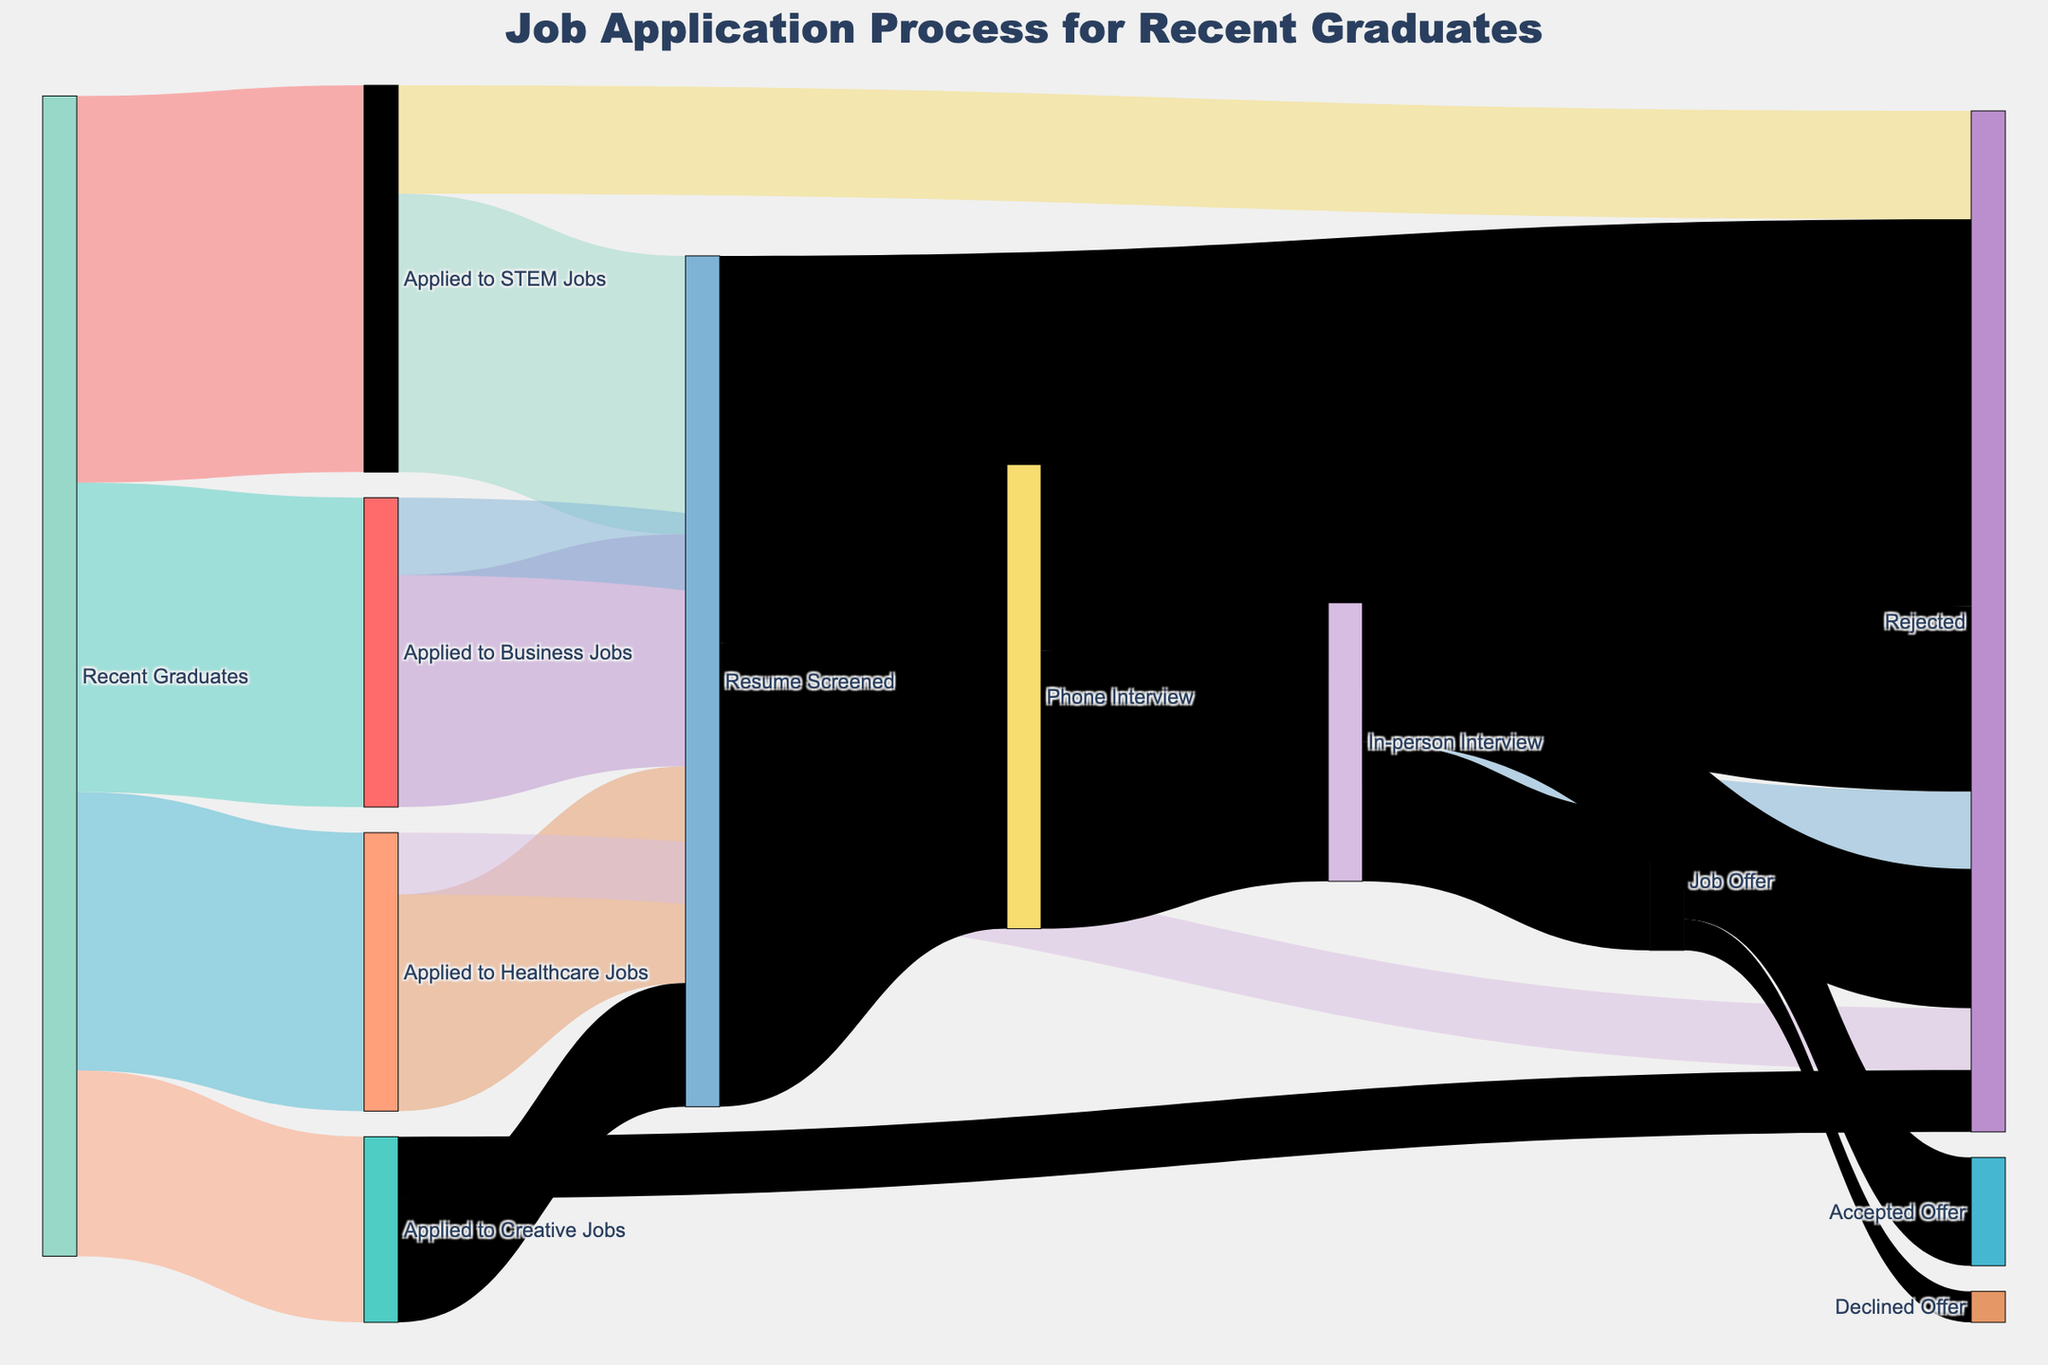What's the title of the diagram? Look at the top center of the diagram where the title is generally placed. The title summarizes the purpose of the diagram.
Answer: Job Application Process for Recent Graduates Which sector received the most applications? Follow the flows starting from "Recent Graduates" to each job sector. The thickness of the flow represents the number of applications.
Answer: STEM Jobs How many graduates' resumes were screened in total across all sectors? Sum the values of resumes screened in each sector: STEM Jobs (1800), Business Jobs (1500), Healthcare Jobs (1400), Creative Jobs (800). 1800 + 1500 + 1400 + 800 = 5500.
Answer: 5500 Compare the number of phone interviews after resume screening and the number of rejections from resume screening. Which is higher? The flow from "Resume Screened" to "Phone Interview" is 3000, and from "Resume Screened" to "Rejected" is 2500. Compare these two numbers.
Answer: Phone interviews are higher How many total job offers were given after in-person interviews? Follow the flows from "In-person Interview" to "Job Offer". The value for this connection is 900.
Answer: 900 Out of the job offers, how many were declined? Follow the flow from "Job Offer" to "Declined Offer". The value for this connection is 200.
Answer: 200 What's the ratio of accepted offers to declined offers? Divide the accepted offers by the declined offers. Accepted Offers are 700, and Declined Offers are 200. 700 / 200 = 3.5.
Answer: 3.5 Compare the number of graduates who applied to Healthcare Jobs versus Creative Jobs. Which one is higher? Follow the initial flows from "Recent Graduates" to each job sector. Healthcare Jobs received 1800 applications, and Creative Jobs received 1200 applications.
Answer: Healthcare Jobs What is the rejection rate at the in-person interview stage? To find the rejection rate at the in-person interview stage, take the number of rejections (900) and divide by the total number of in-person interviews (1800). 900 / 1800 = 0.5, or 50%.
Answer: 50% Which stage sees the highest number of rejections overall? Compare the number of rejections at the different rejection stages: after applying, after resume screening, after phone interviews, and after in-person interviews. The highest value is from resume screening (2500).
Answer: Resume screening How many graduates went from applying to actually accepting a job offer? Trace the path from "Recent Graduates" to "Accepted Offer". Look at the cascading values: 2500 + 2000 + 1800 + 1200 graduates applied for various jobs, then follow the path through each process and summing accepted offers (700).
Answer: 700 